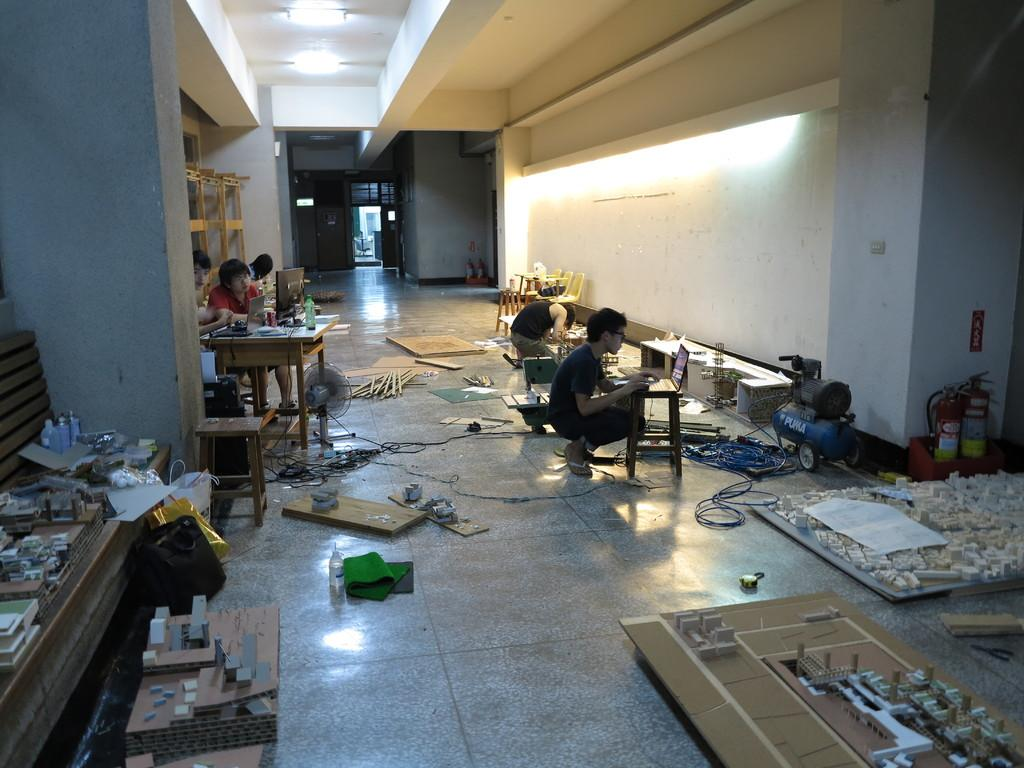What are the people in the image doing? The people in the image are sitting. What type of objects can be seen in the image? There are wooden objects in the image. What structural elements are present in the image? There are walls and a roof in the image. What can be used for illumination in the image? There are lights in the image. What type of books can be found in the stomach of the person in the image? There is no mention of a stomach or books in the image; it only shows people sitting with wooden objects, walls, lights, and a roof. 